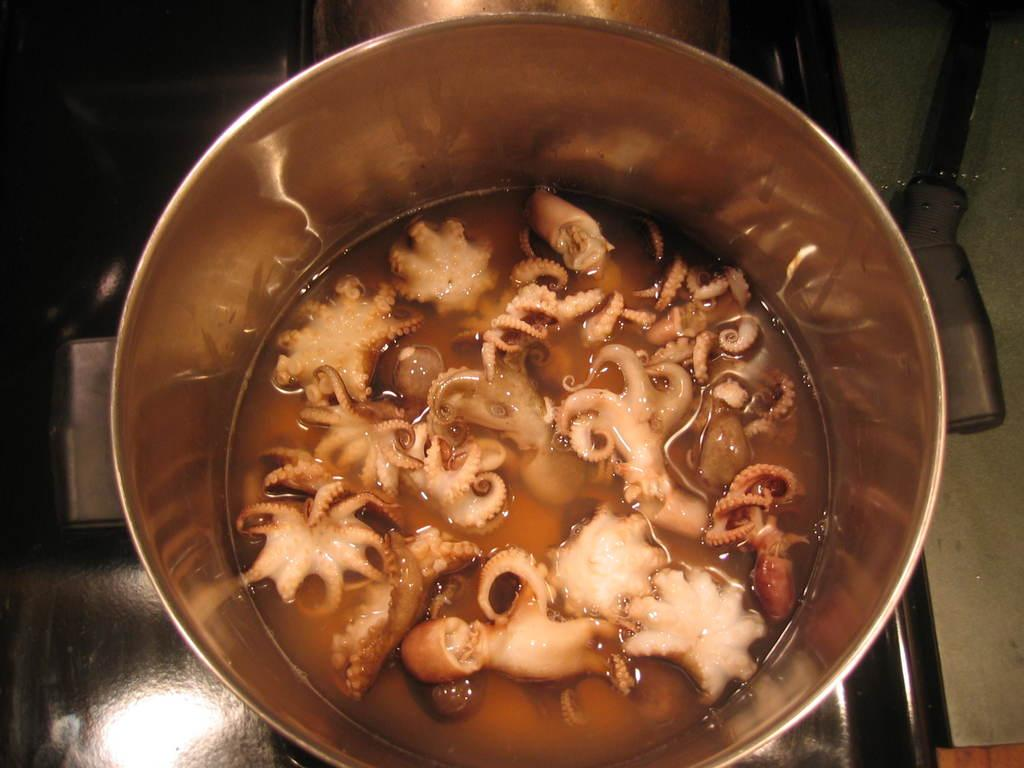What type of seafood is in the soup in the image? There are octopuses in a soup in the image. What is the soup contained in? The soup is in a bowl. Where is the bowl with the soup located? The bowl with the soup is on a stove. How many grapes are floating in the soup in the image? There are no grapes present in the image; the soup contains octopuses. 